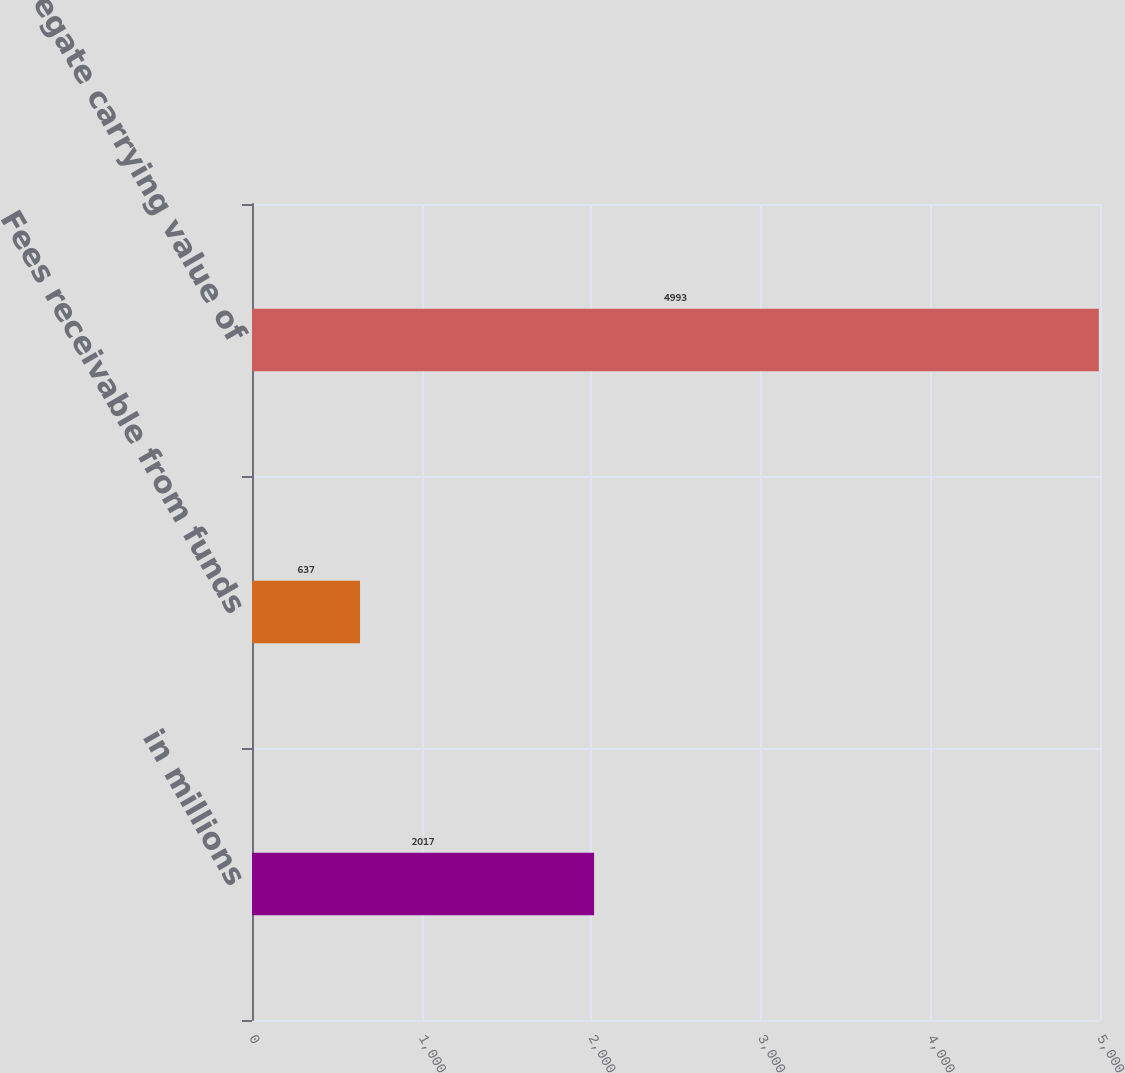<chart> <loc_0><loc_0><loc_500><loc_500><bar_chart><fcel>in millions<fcel>Fees receivable from funds<fcel>Aggregate carrying value of<nl><fcel>2017<fcel>637<fcel>4993<nl></chart> 